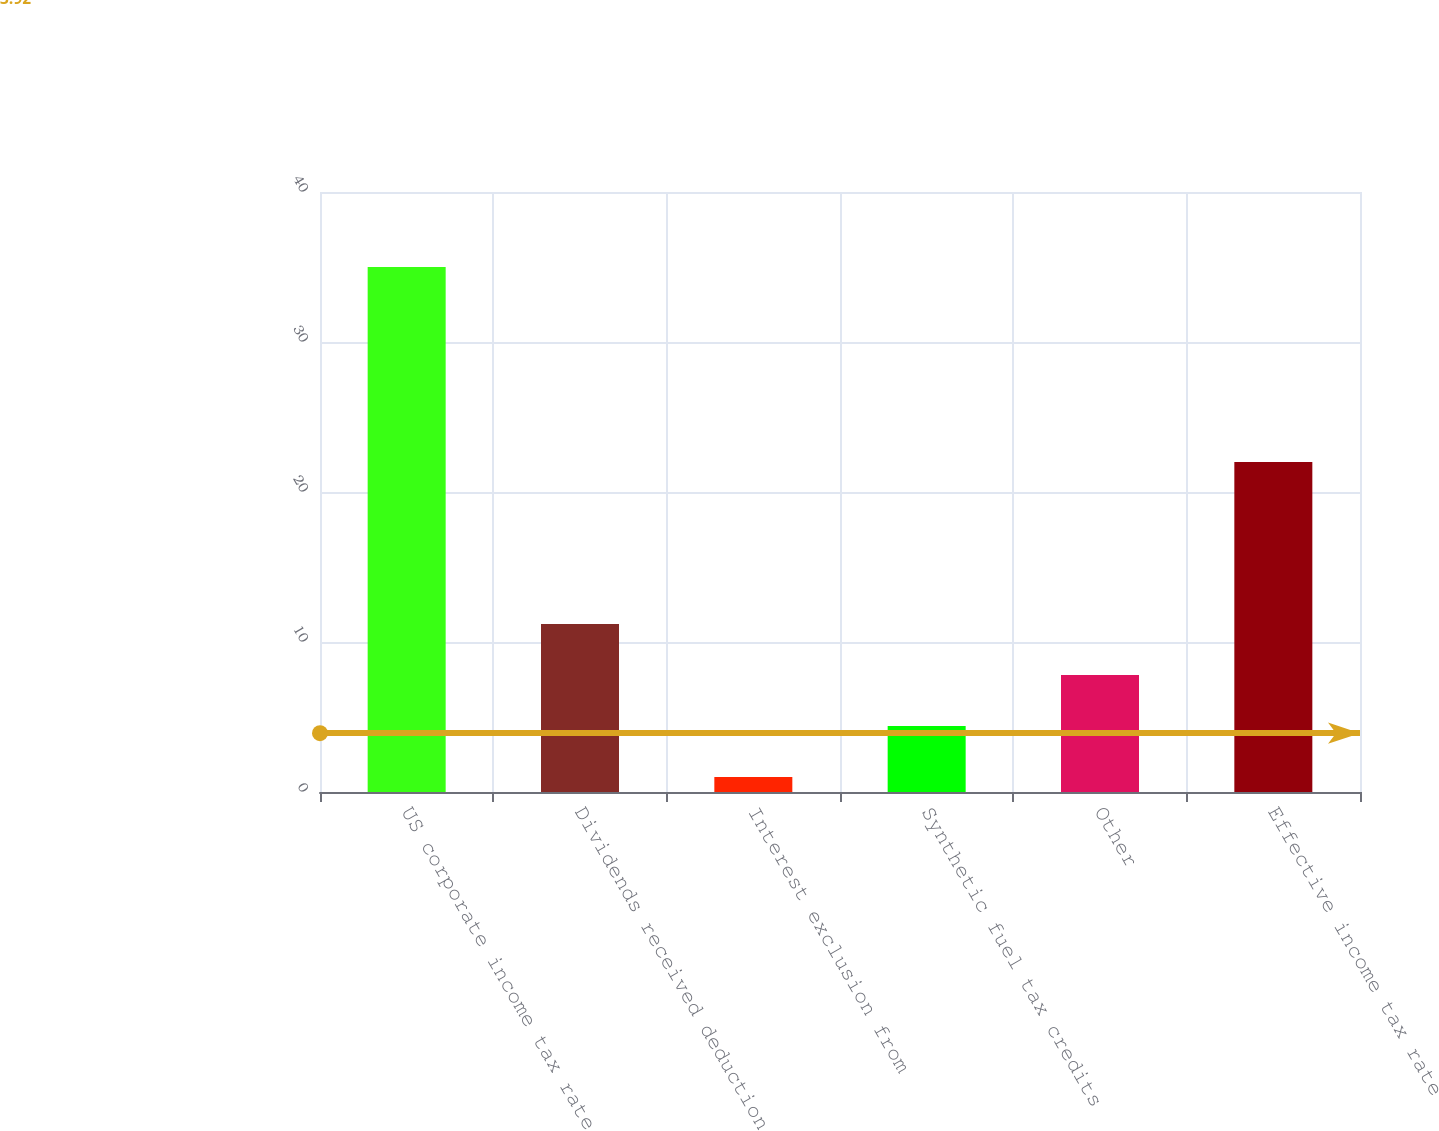Convert chart to OTSL. <chart><loc_0><loc_0><loc_500><loc_500><bar_chart><fcel>US corporate income tax rate<fcel>Dividends received deduction<fcel>Interest exclusion from<fcel>Synthetic fuel tax credits<fcel>Other<fcel>Effective income tax rate<nl><fcel>35<fcel>11.2<fcel>1<fcel>4.4<fcel>7.8<fcel>22<nl></chart> 